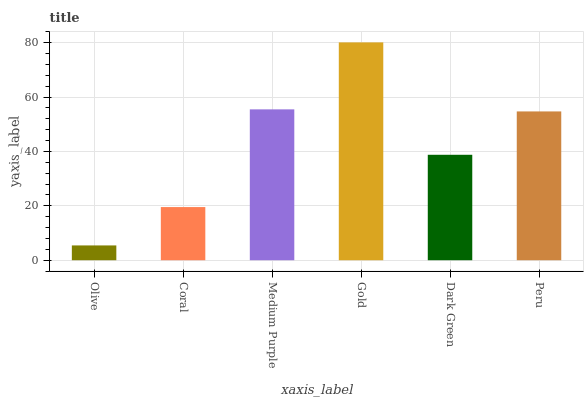Is Olive the minimum?
Answer yes or no. Yes. Is Gold the maximum?
Answer yes or no. Yes. Is Coral the minimum?
Answer yes or no. No. Is Coral the maximum?
Answer yes or no. No. Is Coral greater than Olive?
Answer yes or no. Yes. Is Olive less than Coral?
Answer yes or no. Yes. Is Olive greater than Coral?
Answer yes or no. No. Is Coral less than Olive?
Answer yes or no. No. Is Peru the high median?
Answer yes or no. Yes. Is Dark Green the low median?
Answer yes or no. Yes. Is Medium Purple the high median?
Answer yes or no. No. Is Gold the low median?
Answer yes or no. No. 